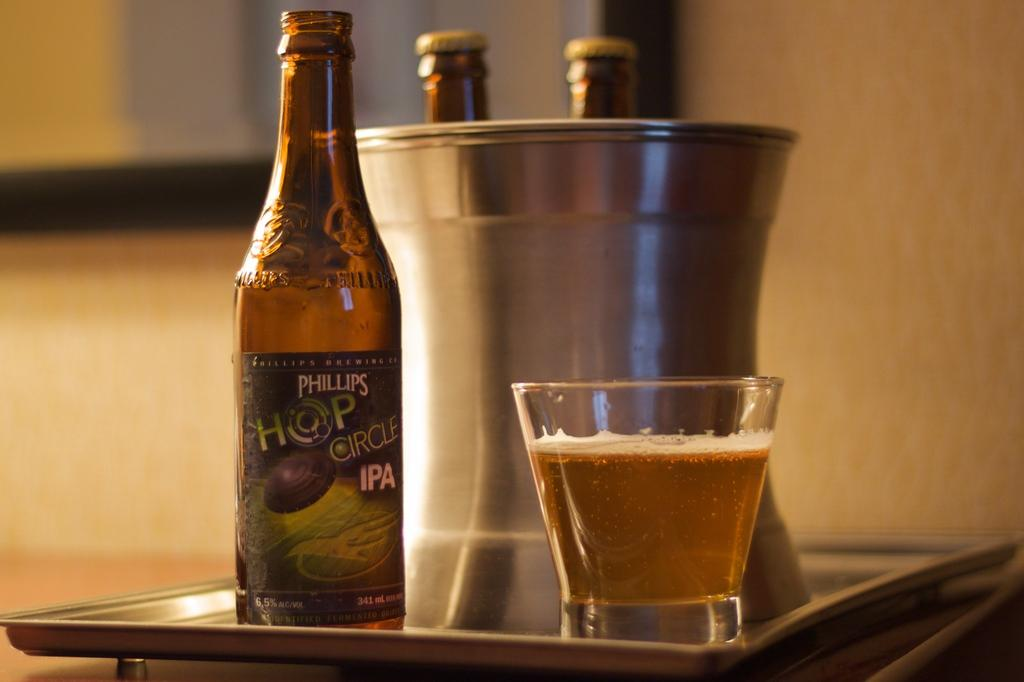Provide a one-sentence caption for the provided image. Cup of beer next to a bottle of "Phillips Hop Circle IPA" beer. 